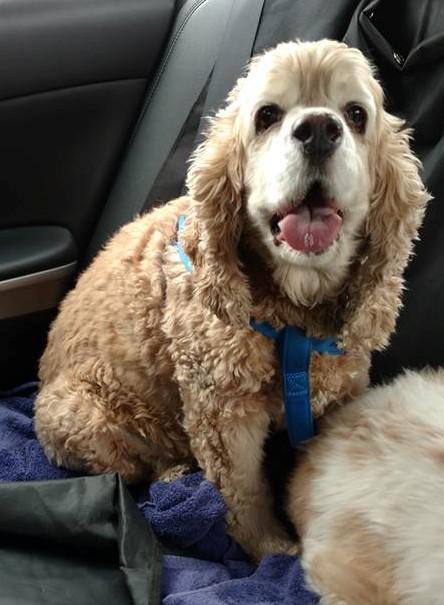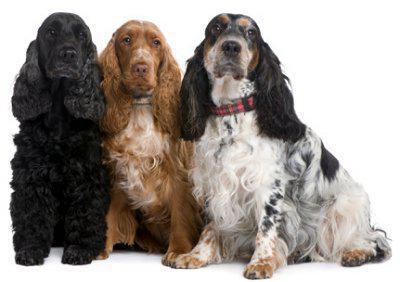The first image is the image on the left, the second image is the image on the right. For the images shown, is this caption "One image shows three dogs sitting in a row." true? Answer yes or no. Yes. 